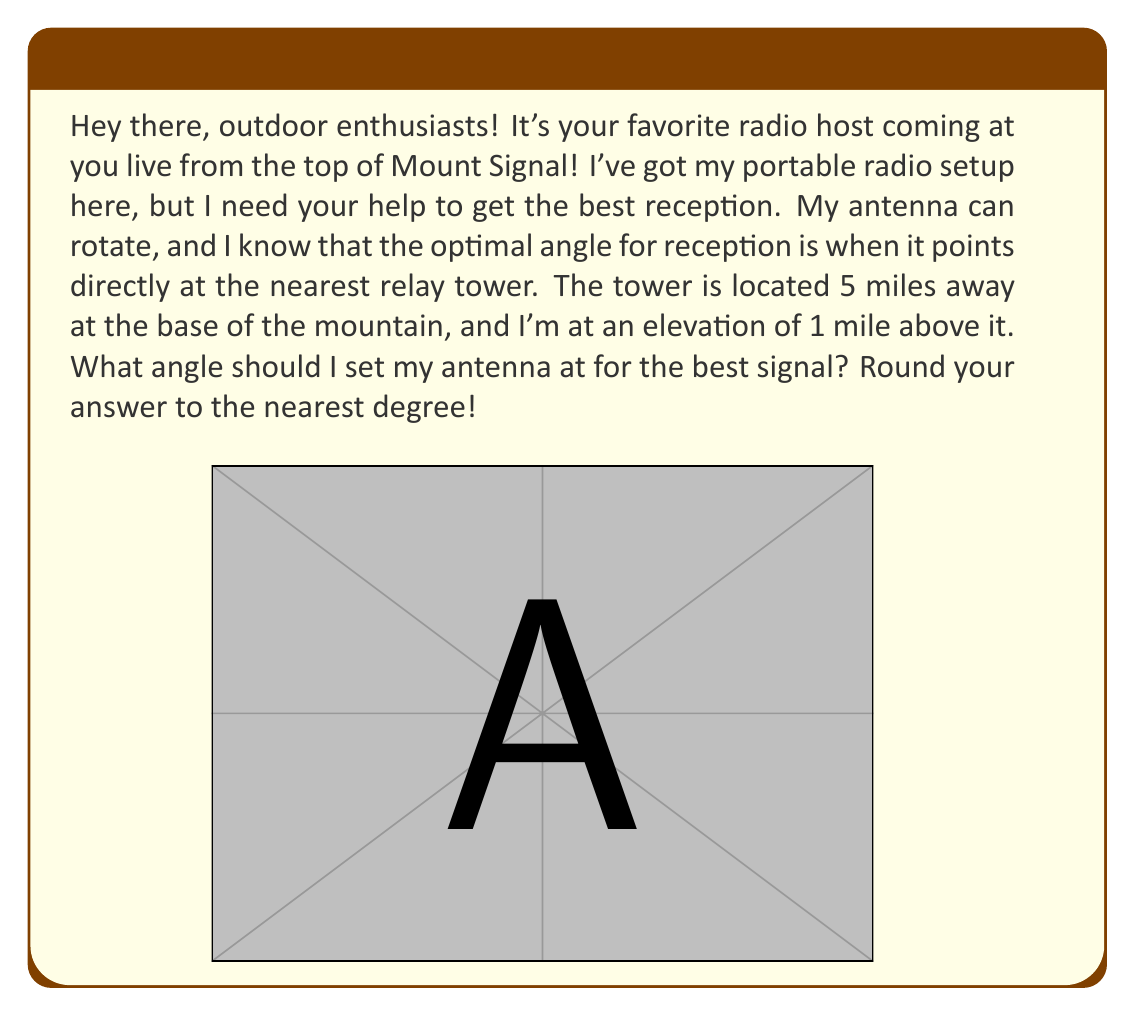Give your solution to this math problem. Let's approach this step-by-step using trigonometry:

1) First, we need to identify the right triangle in this scenario. The antenna position (where you are) forms the right angle, with the tower at the base and your position at the top of the triangle.

2) We're looking for the angle $\theta$ that the antenna should be pointed downward from the horizontal.

3) In this right triangle:
   - The adjacent side to $\theta$ is the horizontal distance to the tower (5 miles)
   - The opposite side to $\theta$ is the elevation difference (1 mile)

4) We can use the arctangent function to find this angle:

   $$\theta = \arctan(\frac{\text{opposite}}{\text{adjacent}})$$

5) Plugging in our values:

   $$\theta = \arctan(\frac{1}{5})$$

6) Using a calculator (or your phone's scientific calculator app for us outdoor types!):

   $$\theta \approx 0.1974 \text{ radians}$$

7) Convert to degrees:

   $$\theta \approx 0.1974 \times \frac{180^{\circ}}{\pi} \approx 11.31^{\circ}$$

8) Rounding to the nearest degree as requested:

   $$\theta \approx 11^{\circ}$$

Therefore, you should angle your antenna 11 degrees downward from the horizontal for optimal reception.
Answer: 11 degrees 